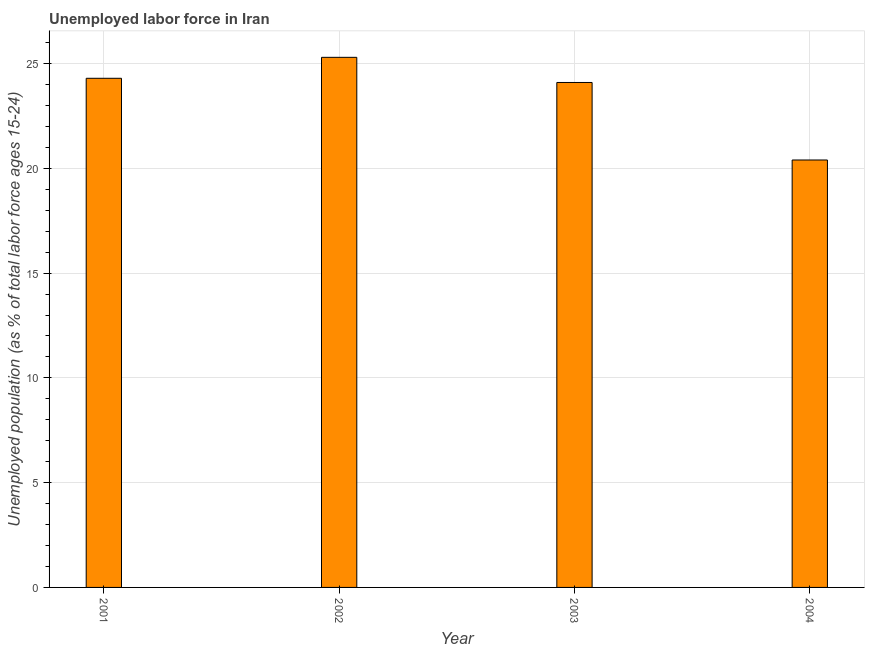Does the graph contain any zero values?
Ensure brevity in your answer.  No. Does the graph contain grids?
Give a very brief answer. Yes. What is the title of the graph?
Keep it short and to the point. Unemployed labor force in Iran. What is the label or title of the X-axis?
Keep it short and to the point. Year. What is the label or title of the Y-axis?
Your answer should be very brief. Unemployed population (as % of total labor force ages 15-24). What is the total unemployed youth population in 2003?
Provide a succinct answer. 24.1. Across all years, what is the maximum total unemployed youth population?
Keep it short and to the point. 25.3. Across all years, what is the minimum total unemployed youth population?
Make the answer very short. 20.4. In which year was the total unemployed youth population minimum?
Provide a succinct answer. 2004. What is the sum of the total unemployed youth population?
Your response must be concise. 94.1. What is the difference between the total unemployed youth population in 2001 and 2003?
Keep it short and to the point. 0.2. What is the average total unemployed youth population per year?
Offer a terse response. 23.52. What is the median total unemployed youth population?
Keep it short and to the point. 24.2. Do a majority of the years between 2001 and 2004 (inclusive) have total unemployed youth population greater than 17 %?
Make the answer very short. Yes. What is the ratio of the total unemployed youth population in 2001 to that in 2004?
Keep it short and to the point. 1.19. Is the total unemployed youth population in 2003 less than that in 2004?
Give a very brief answer. No. What is the difference between the highest and the second highest total unemployed youth population?
Make the answer very short. 1. Is the sum of the total unemployed youth population in 2003 and 2004 greater than the maximum total unemployed youth population across all years?
Provide a succinct answer. Yes. What is the difference between the highest and the lowest total unemployed youth population?
Offer a very short reply. 4.9. In how many years, is the total unemployed youth population greater than the average total unemployed youth population taken over all years?
Keep it short and to the point. 3. How many bars are there?
Ensure brevity in your answer.  4. Are all the bars in the graph horizontal?
Your response must be concise. No. What is the difference between two consecutive major ticks on the Y-axis?
Provide a short and direct response. 5. What is the Unemployed population (as % of total labor force ages 15-24) of 2001?
Ensure brevity in your answer.  24.3. What is the Unemployed population (as % of total labor force ages 15-24) of 2002?
Keep it short and to the point. 25.3. What is the Unemployed population (as % of total labor force ages 15-24) of 2003?
Ensure brevity in your answer.  24.1. What is the Unemployed population (as % of total labor force ages 15-24) in 2004?
Keep it short and to the point. 20.4. What is the difference between the Unemployed population (as % of total labor force ages 15-24) in 2001 and 2002?
Offer a very short reply. -1. What is the difference between the Unemployed population (as % of total labor force ages 15-24) in 2001 and 2003?
Keep it short and to the point. 0.2. What is the difference between the Unemployed population (as % of total labor force ages 15-24) in 2001 and 2004?
Offer a terse response. 3.9. What is the difference between the Unemployed population (as % of total labor force ages 15-24) in 2002 and 2004?
Offer a very short reply. 4.9. What is the difference between the Unemployed population (as % of total labor force ages 15-24) in 2003 and 2004?
Keep it short and to the point. 3.7. What is the ratio of the Unemployed population (as % of total labor force ages 15-24) in 2001 to that in 2003?
Make the answer very short. 1.01. What is the ratio of the Unemployed population (as % of total labor force ages 15-24) in 2001 to that in 2004?
Your answer should be compact. 1.19. What is the ratio of the Unemployed population (as % of total labor force ages 15-24) in 2002 to that in 2003?
Your answer should be compact. 1.05. What is the ratio of the Unemployed population (as % of total labor force ages 15-24) in 2002 to that in 2004?
Ensure brevity in your answer.  1.24. What is the ratio of the Unemployed population (as % of total labor force ages 15-24) in 2003 to that in 2004?
Ensure brevity in your answer.  1.18. 